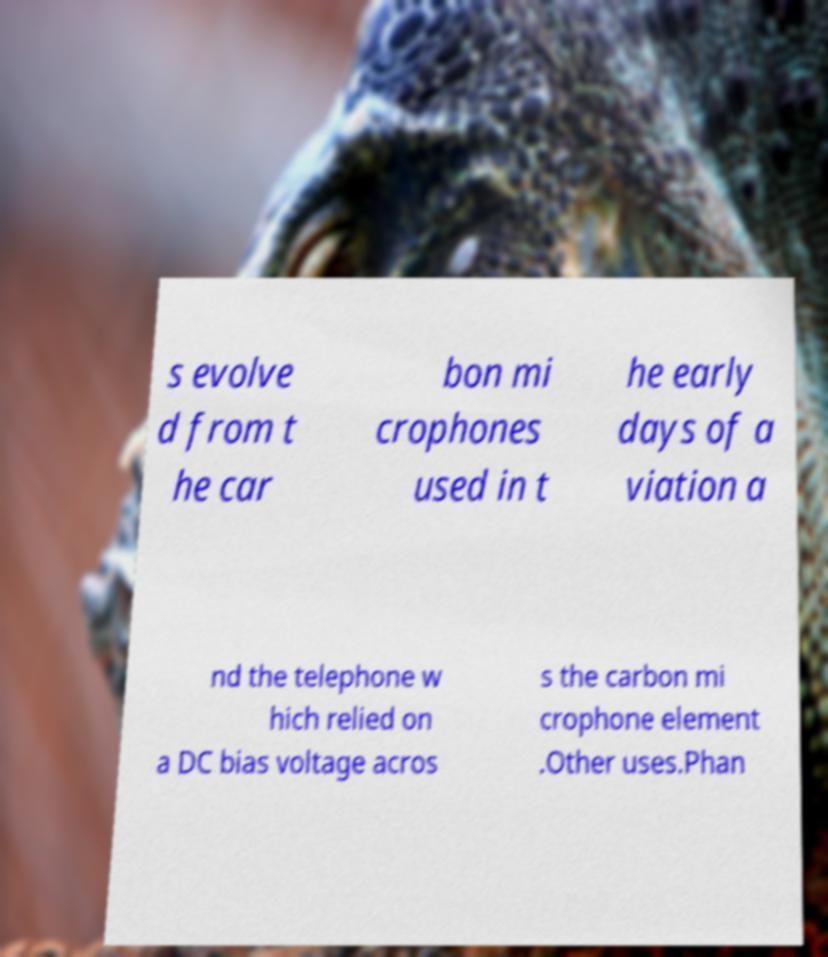Could you extract and type out the text from this image? s evolve d from t he car bon mi crophones used in t he early days of a viation a nd the telephone w hich relied on a DC bias voltage acros s the carbon mi crophone element .Other uses.Phan 